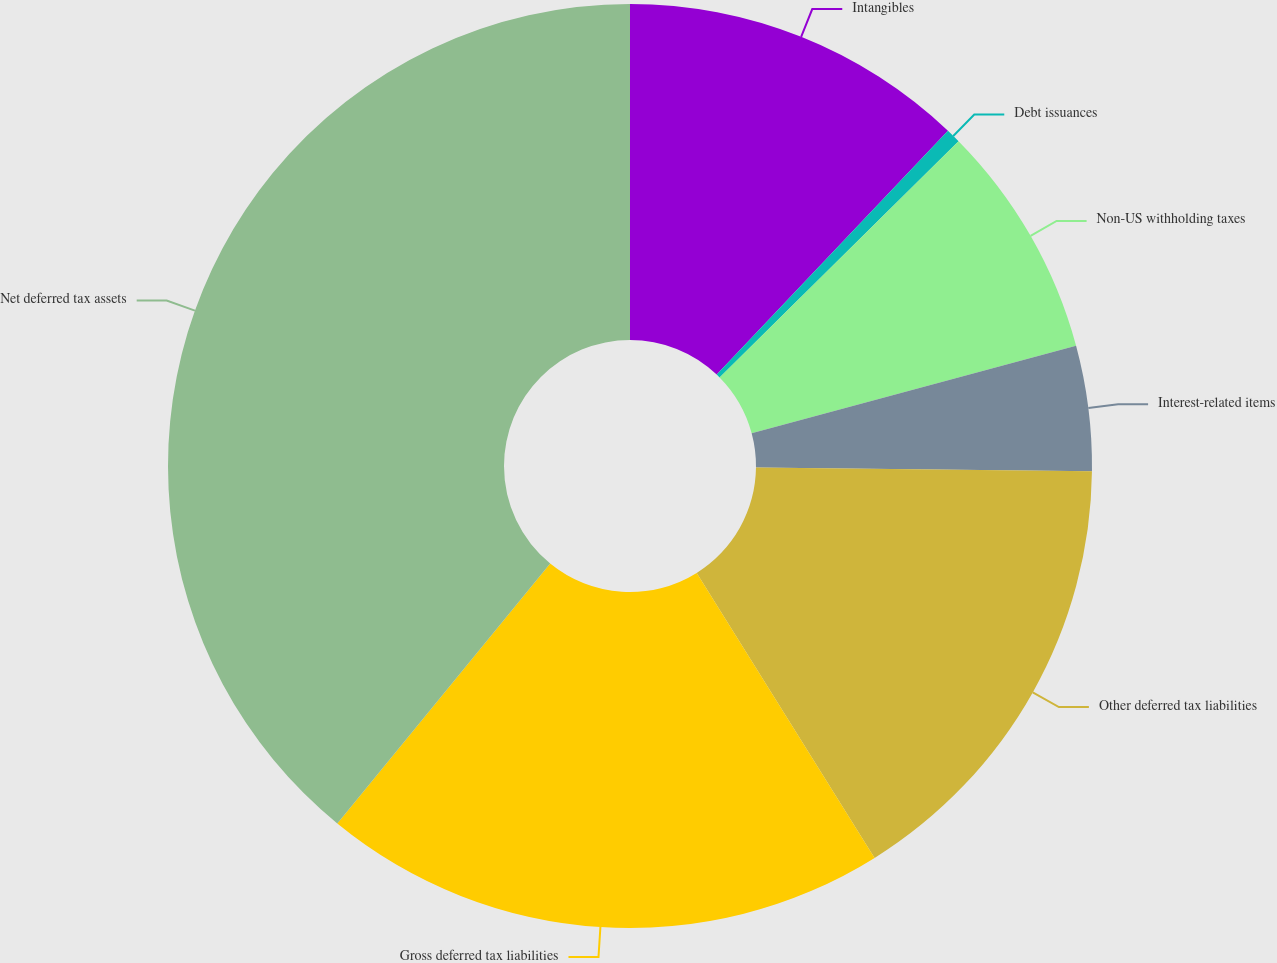<chart> <loc_0><loc_0><loc_500><loc_500><pie_chart><fcel>Intangibles<fcel>Debt issuances<fcel>Non-US withholding taxes<fcel>Interest-related items<fcel>Other deferred tax liabilities<fcel>Gross deferred tax liabilities<fcel>Net deferred tax assets<nl><fcel>12.08%<fcel>0.51%<fcel>8.22%<fcel>4.37%<fcel>15.94%<fcel>19.8%<fcel>39.08%<nl></chart> 